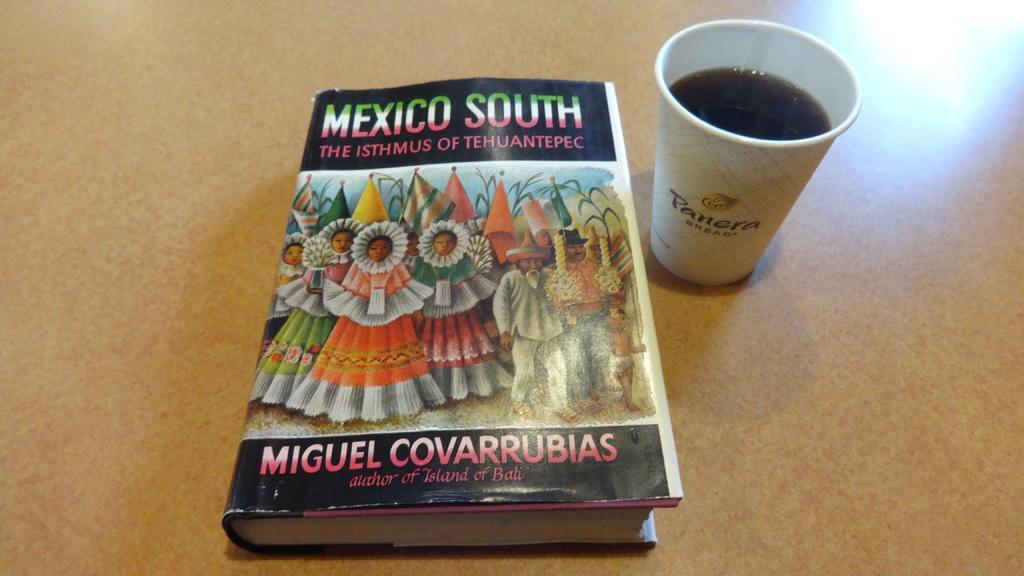Could you give a brief overview of what you see in this image? This image consists of a book and a cup. On the book, there is a picture of some people. 